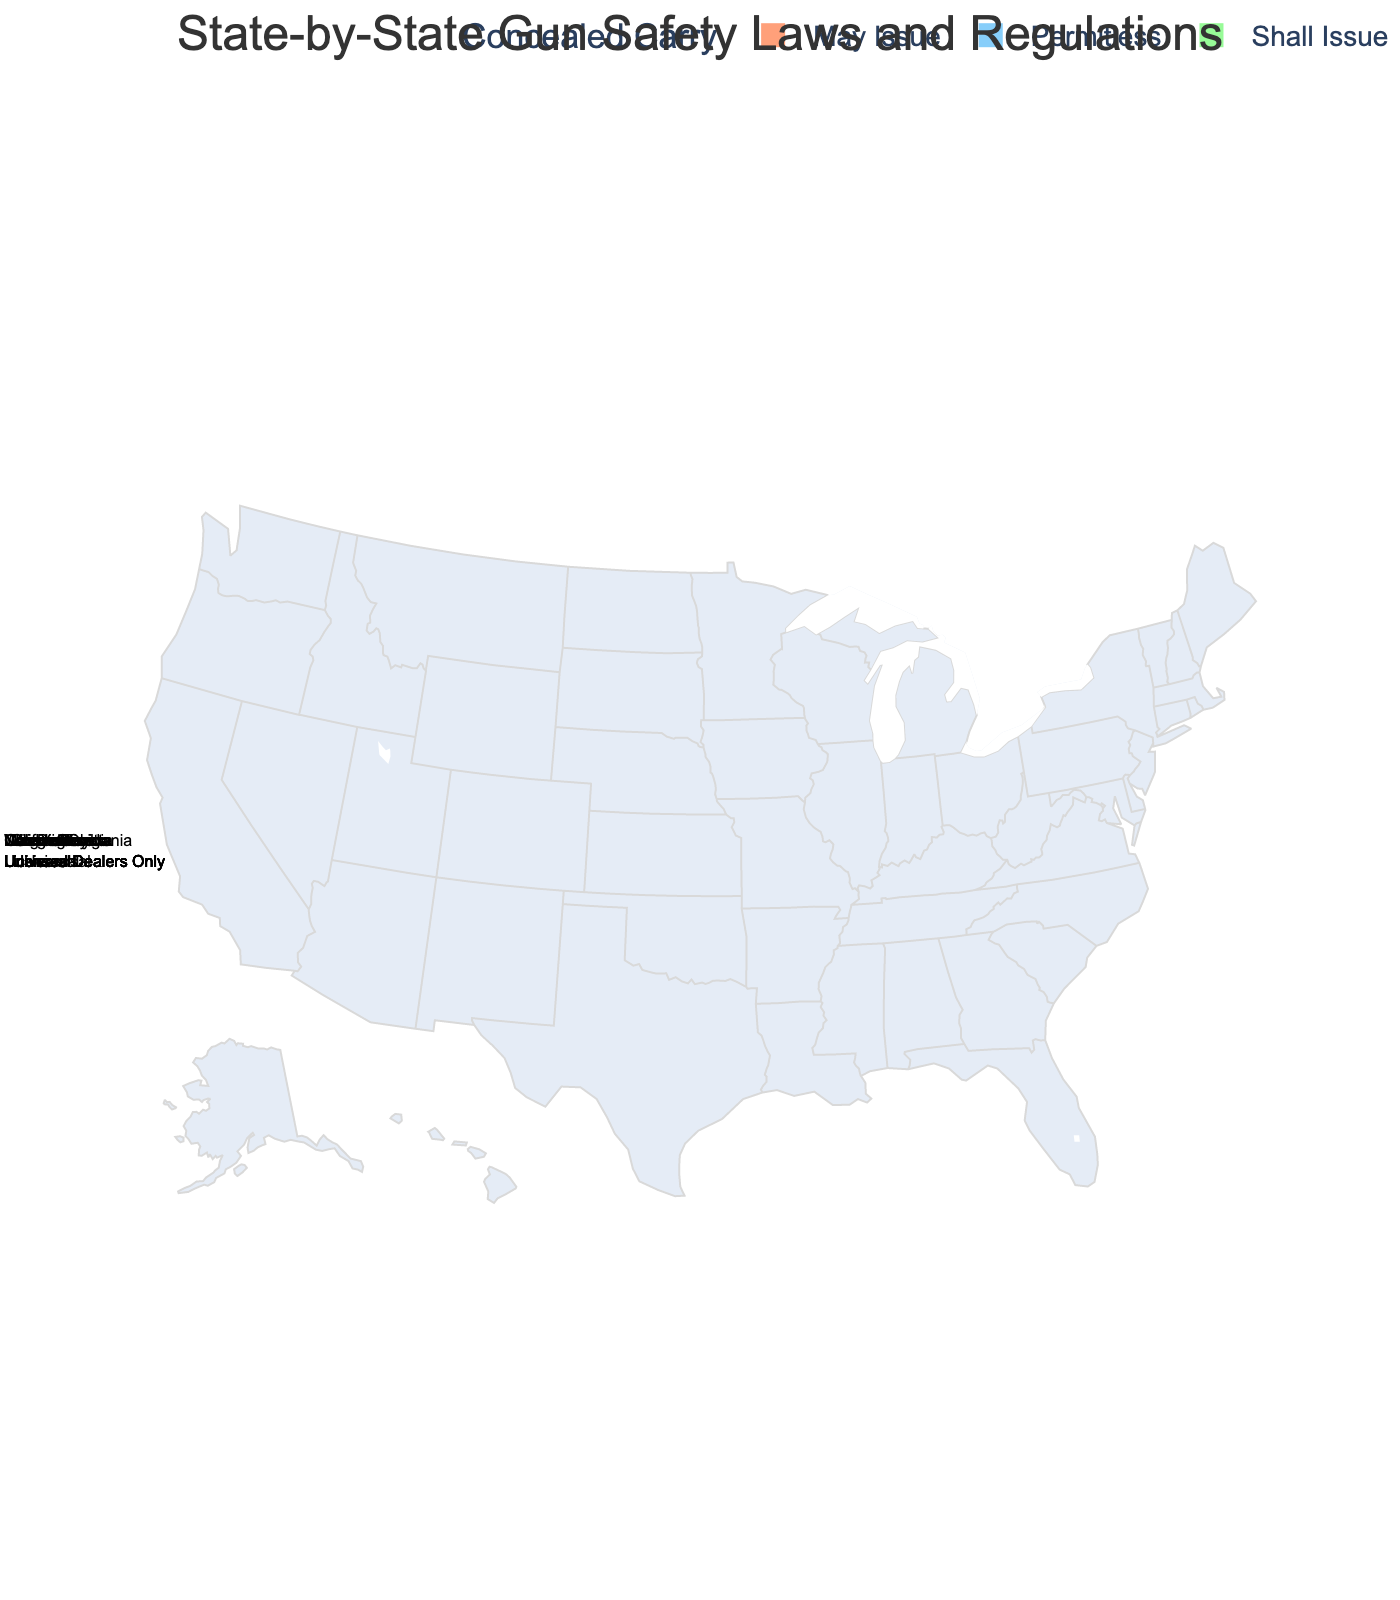Which states have a "May Issue" policy for concealed carry? By looking at the figure, the states colored with '#FFA07A' represent the "May Issue" policy for concealed carry. The states with this color are California, New York, Massachusetts, and New Jersey.
Answer: California, New York, Massachusetts, New Jersey Which state has the longest waiting period for firearm purchases? By examining the waiting period data displayed on the map, the state with the longest waiting period is Illinois, with a waiting period of 72 hours.
Answer: Illinois How many states require universal background checks? Universal background checks are specifically noted in the hover data for each state. Counting the states labeled as requiring "Universal" background checks, we find there are eight states: California, New York, Illinois, Washington, Colorado, Massachusetts, Oregon, and New Jersey.
Answer: Eight Do any states with "Permitless" concealed carry have safe storage laws? "Permitless" states are colored '#87CEFA'. By looking at these states and checking their hover data for safe storage laws, none of the "Permitless" states (Texas, Ohio, Georgia, or Arizona) have safe storage laws.
Answer: No How many states have a waiting period greater than or equal to 7 days? The waiting period data can be checked quickly from the hover information. The states with a waiting period of 7 days or more are California (10 days), Washington (10 days), Massachusetts (7 days), and Illinois (72 hours). So, there are 4 states.
Answer: Four Which state has the most comprehensive set of gun safety laws? A comprehensive set of gun safety laws would include universal background checks, safe storage laws, child access prevention, and a waiting period. By checking these criteria on the hover data, California has all these elements and the longest waiting period (10 days), making it the most comprehensive.
Answer: California Which states allow concealed carry without a permit? "Permitless" states are colored '#87CEFA'. The states with this policy are Texas, Ohio, Georgia, and Arizona.
Answer: Texas, Ohio, Georgia, Arizona Which states only perform background checks at licensed dealers? By examining the hover data, the states that have "Licensed Dealers Only" for background checks are Texas, Florida, Pennsylvania, Ohio, Georgia, and Arizona.
Answer: Texas, Florida, Pennsylvania, Ohio, Georgia, Arizona Compare the waiting periods between Massachusetts and Florida. Which state has a longer waiting period? The hover data shows that Massachusetts has a waiting period of 7 days, whereas Florida has a waiting period of 3 days. Thus, Massachusetts has a longer waiting period than Florida.
Answer: Massachusetts 